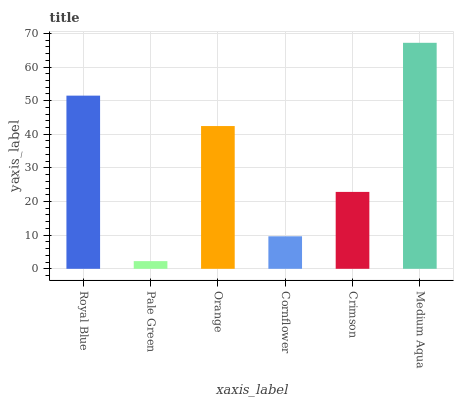Is Pale Green the minimum?
Answer yes or no. Yes. Is Medium Aqua the maximum?
Answer yes or no. Yes. Is Orange the minimum?
Answer yes or no. No. Is Orange the maximum?
Answer yes or no. No. Is Orange greater than Pale Green?
Answer yes or no. Yes. Is Pale Green less than Orange?
Answer yes or no. Yes. Is Pale Green greater than Orange?
Answer yes or no. No. Is Orange less than Pale Green?
Answer yes or no. No. Is Orange the high median?
Answer yes or no. Yes. Is Crimson the low median?
Answer yes or no. Yes. Is Royal Blue the high median?
Answer yes or no. No. Is Pale Green the low median?
Answer yes or no. No. 